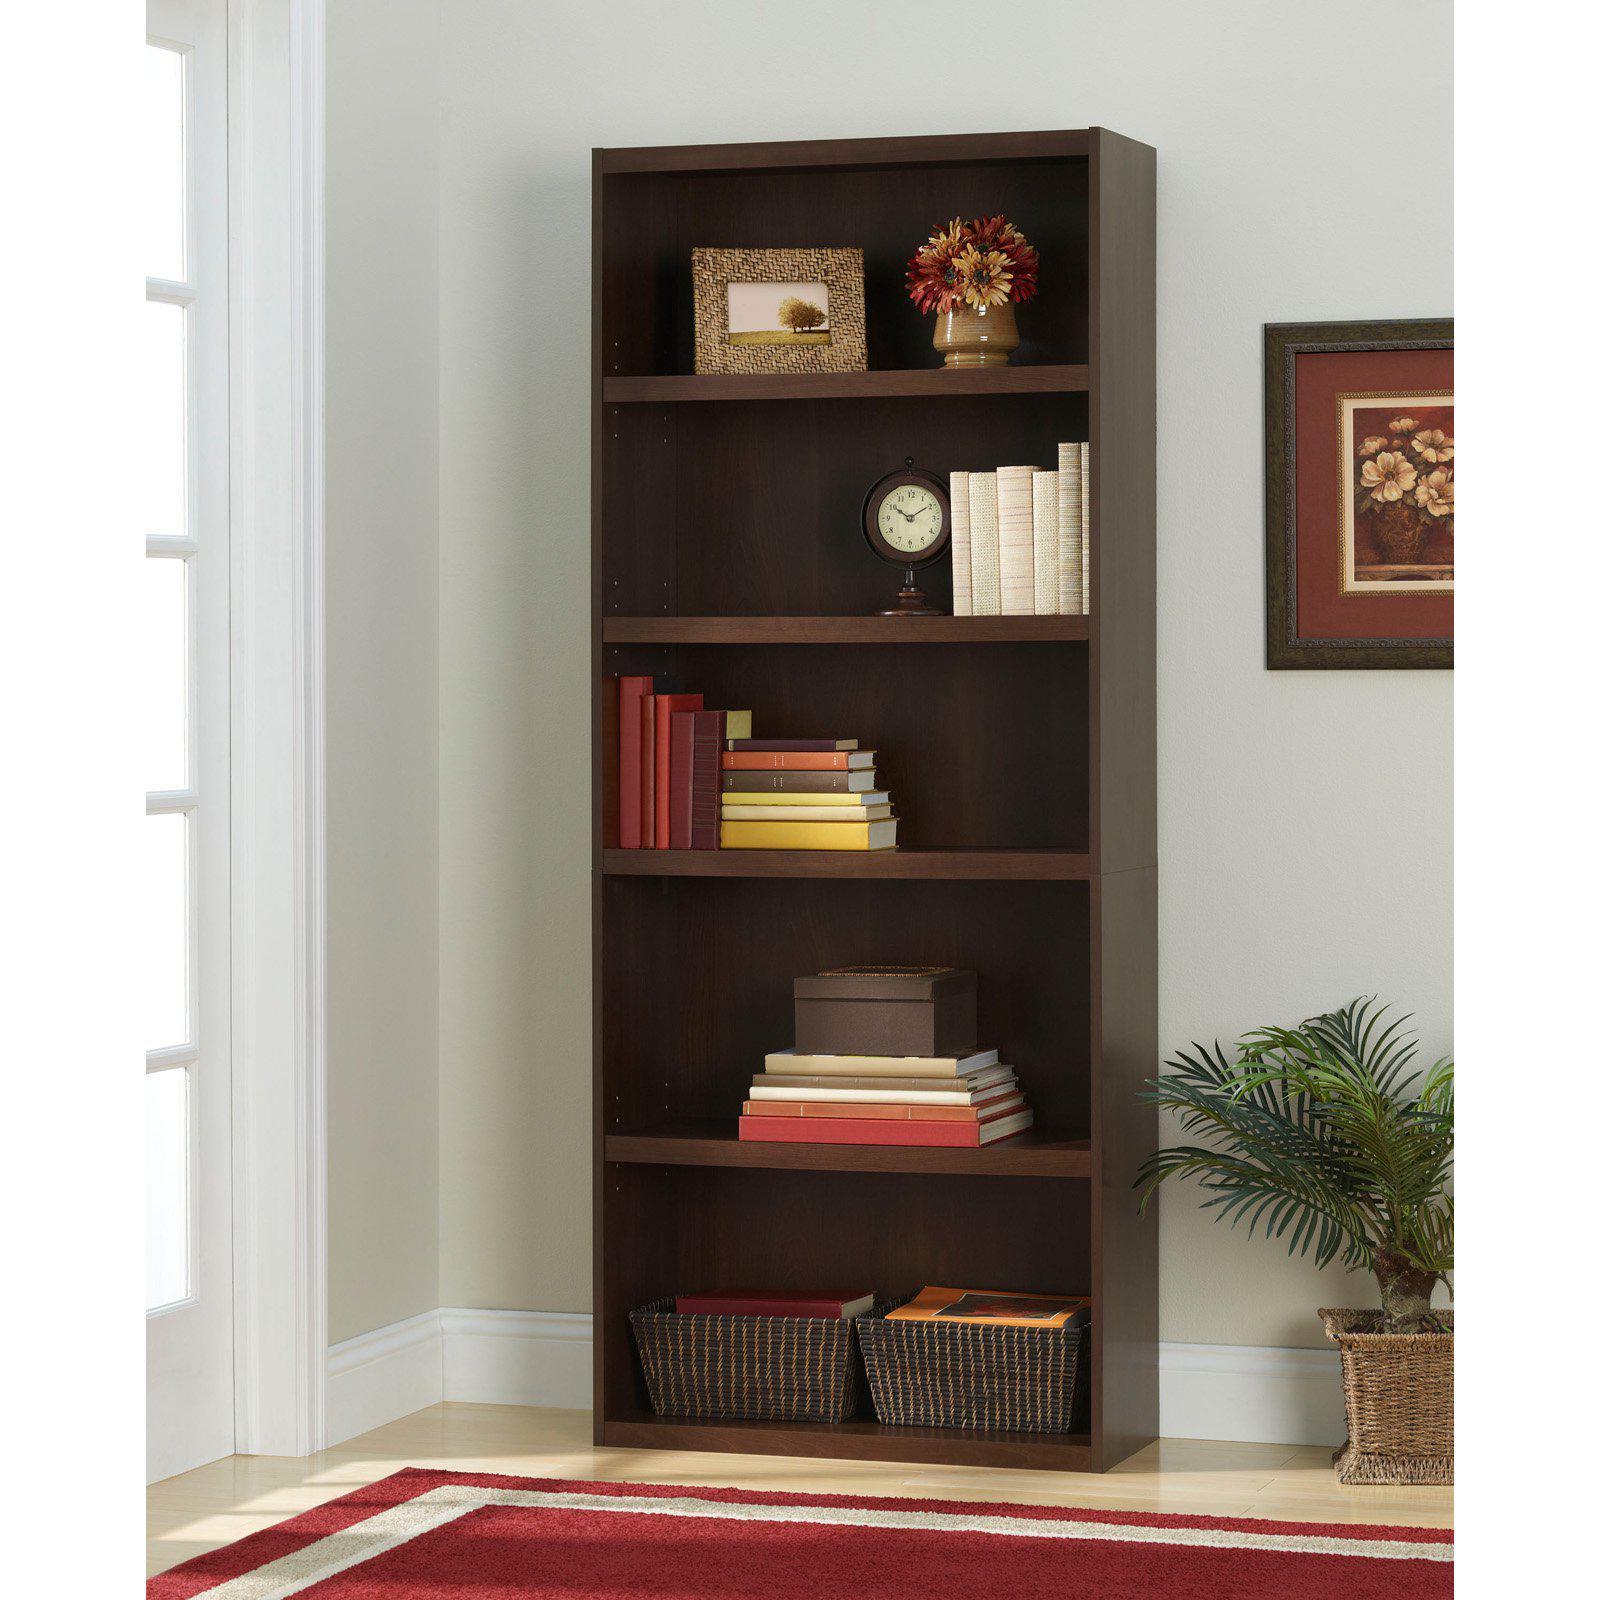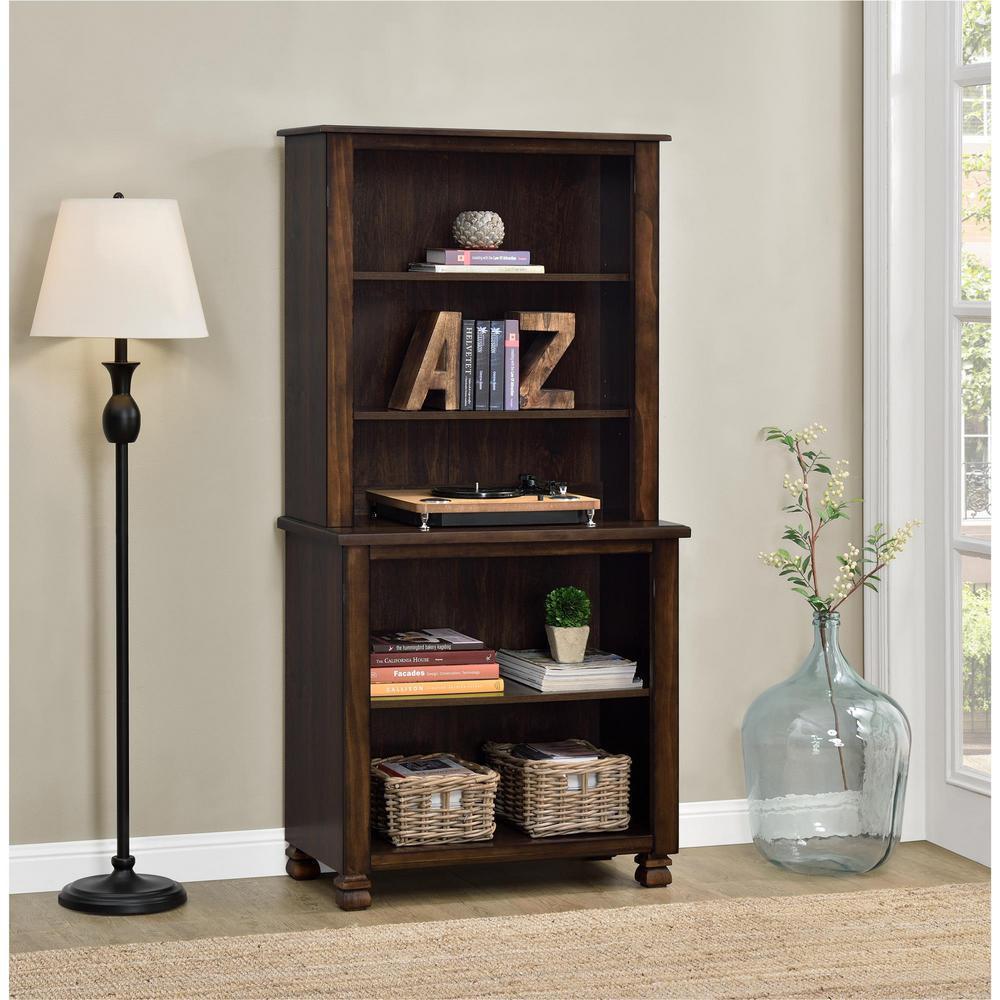The first image is the image on the left, the second image is the image on the right. Analyze the images presented: Is the assertion "One of the bookshelves is white." valid? Answer yes or no. No. 